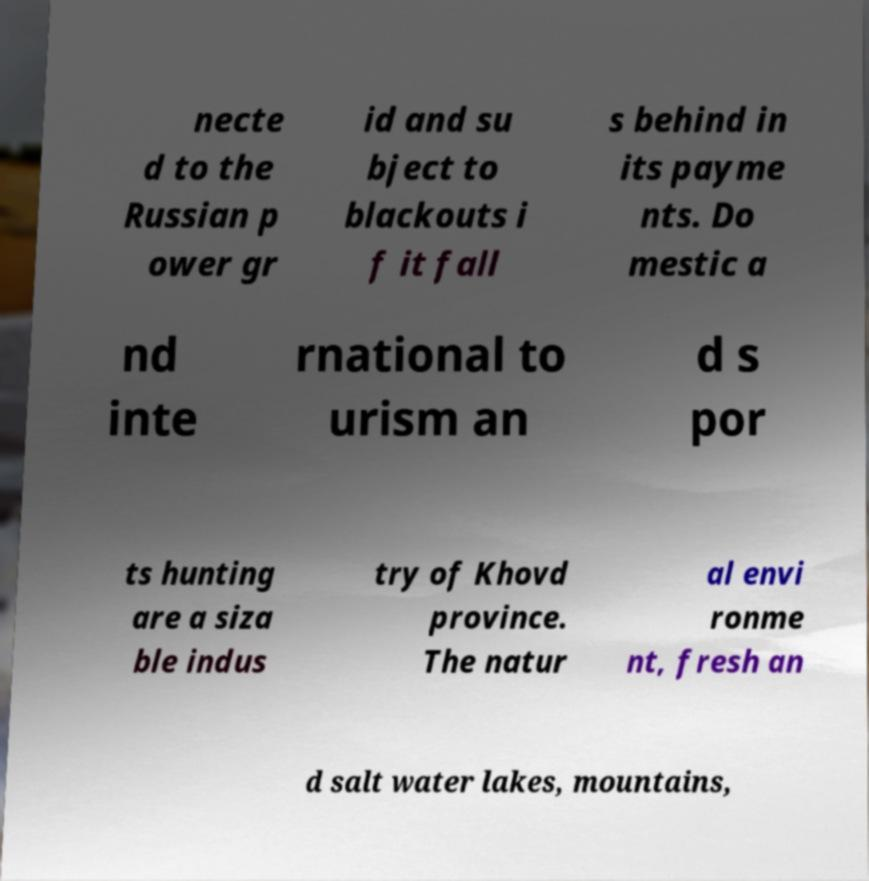There's text embedded in this image that I need extracted. Can you transcribe it verbatim? necte d to the Russian p ower gr id and su bject to blackouts i f it fall s behind in its payme nts. Do mestic a nd inte rnational to urism an d s por ts hunting are a siza ble indus try of Khovd province. The natur al envi ronme nt, fresh an d salt water lakes, mountains, 